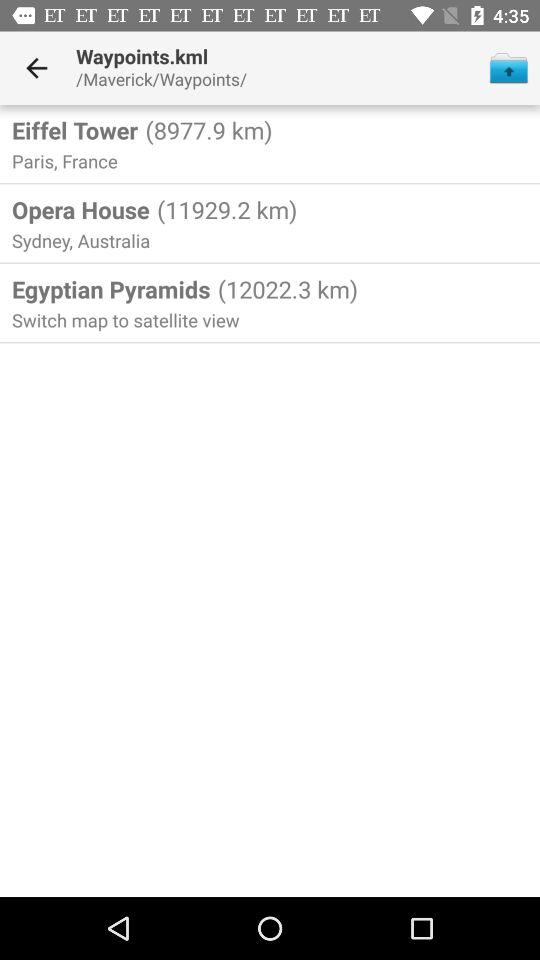What is the mentioned location for map view? The mentioned location is Egyptian Pyramids. 